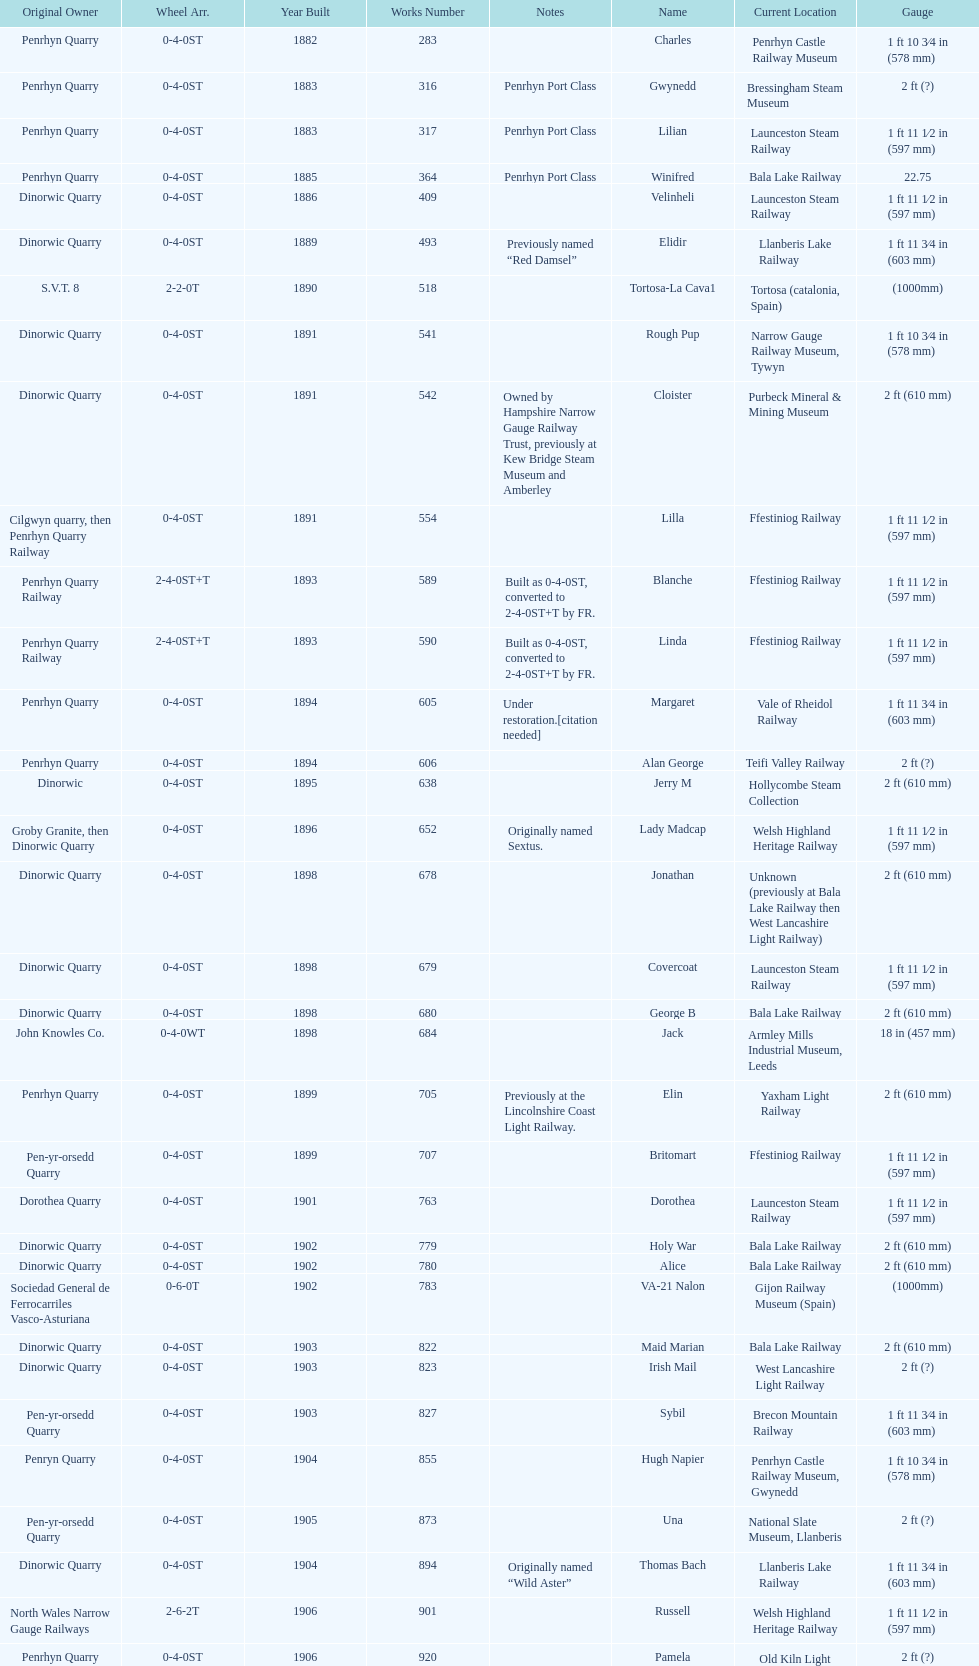Write the full table. {'header': ['Original Owner', 'Wheel Arr.', 'Year Built', 'Works Number', 'Notes', 'Name', 'Current Location', 'Gauge'], 'rows': [['Penrhyn Quarry', '0-4-0ST', '1882', '283', '', 'Charles', 'Penrhyn Castle Railway Museum', '1\xa0ft 10\xa03⁄4\xa0in (578\xa0mm)'], ['Penrhyn Quarry', '0-4-0ST', '1883', '316', 'Penrhyn Port Class', 'Gwynedd', 'Bressingham Steam Museum', '2\xa0ft (?)'], ['Penrhyn Quarry', '0-4-0ST', '1883', '317', 'Penrhyn Port Class', 'Lilian', 'Launceston Steam Railway', '1\xa0ft 11\xa01⁄2\xa0in (597\xa0mm)'], ['Penrhyn Quarry', '0-4-0ST', '1885', '364', 'Penrhyn Port Class', 'Winifred', 'Bala Lake Railway', '22.75'], ['Dinorwic Quarry', '0-4-0ST', '1886', '409', '', 'Velinheli', 'Launceston Steam Railway', '1\xa0ft 11\xa01⁄2\xa0in (597\xa0mm)'], ['Dinorwic Quarry', '0-4-0ST', '1889', '493', 'Previously named “Red Damsel”', 'Elidir', 'Llanberis Lake Railway', '1\xa0ft 11\xa03⁄4\xa0in (603\xa0mm)'], ['S.V.T. 8', '2-2-0T', '1890', '518', '', 'Tortosa-La Cava1', 'Tortosa (catalonia, Spain)', '(1000mm)'], ['Dinorwic Quarry', '0-4-0ST', '1891', '541', '', 'Rough Pup', 'Narrow Gauge Railway Museum, Tywyn', '1\xa0ft 10\xa03⁄4\xa0in (578\xa0mm)'], ['Dinorwic Quarry', '0-4-0ST', '1891', '542', 'Owned by Hampshire Narrow Gauge Railway Trust, previously at Kew Bridge Steam Museum and Amberley', 'Cloister', 'Purbeck Mineral & Mining Museum', '2\xa0ft (610\xa0mm)'], ['Cilgwyn quarry, then Penrhyn Quarry Railway', '0-4-0ST', '1891', '554', '', 'Lilla', 'Ffestiniog Railway', '1\xa0ft 11\xa01⁄2\xa0in (597\xa0mm)'], ['Penrhyn Quarry Railway', '2-4-0ST+T', '1893', '589', 'Built as 0-4-0ST, converted to 2-4-0ST+T by FR.', 'Blanche', 'Ffestiniog Railway', '1\xa0ft 11\xa01⁄2\xa0in (597\xa0mm)'], ['Penrhyn Quarry Railway', '2-4-0ST+T', '1893', '590', 'Built as 0-4-0ST, converted to 2-4-0ST+T by FR.', 'Linda', 'Ffestiniog Railway', '1\xa0ft 11\xa01⁄2\xa0in (597\xa0mm)'], ['Penrhyn Quarry', '0-4-0ST', '1894', '605', 'Under restoration.[citation needed]', 'Margaret', 'Vale of Rheidol Railway', '1\xa0ft 11\xa03⁄4\xa0in (603\xa0mm)'], ['Penrhyn Quarry', '0-4-0ST', '1894', '606', '', 'Alan George', 'Teifi Valley Railway', '2\xa0ft (?)'], ['Dinorwic', '0-4-0ST', '1895', '638', '', 'Jerry M', 'Hollycombe Steam Collection', '2\xa0ft (610\xa0mm)'], ['Groby Granite, then Dinorwic Quarry', '0-4-0ST', '1896', '652', 'Originally named Sextus.', 'Lady Madcap', 'Welsh Highland Heritage Railway', '1\xa0ft 11\xa01⁄2\xa0in (597\xa0mm)'], ['Dinorwic Quarry', '0-4-0ST', '1898', '678', '', 'Jonathan', 'Unknown (previously at Bala Lake Railway then West Lancashire Light Railway)', '2\xa0ft (610\xa0mm)'], ['Dinorwic Quarry', '0-4-0ST', '1898', '679', '', 'Covercoat', 'Launceston Steam Railway', '1\xa0ft 11\xa01⁄2\xa0in (597\xa0mm)'], ['Dinorwic Quarry', '0-4-0ST', '1898', '680', '', 'George B', 'Bala Lake Railway', '2\xa0ft (610\xa0mm)'], ['John Knowles Co.', '0-4-0WT', '1898', '684', '', 'Jack', 'Armley Mills Industrial Museum, Leeds', '18\xa0in (457\xa0mm)'], ['Penrhyn Quarry', '0-4-0ST', '1899', '705', 'Previously at the Lincolnshire Coast Light Railway.', 'Elin', 'Yaxham Light Railway', '2\xa0ft (610\xa0mm)'], ['Pen-yr-orsedd Quarry', '0-4-0ST', '1899', '707', '', 'Britomart', 'Ffestiniog Railway', '1\xa0ft 11\xa01⁄2\xa0in (597\xa0mm)'], ['Dorothea Quarry', '0-4-0ST', '1901', '763', '', 'Dorothea', 'Launceston Steam Railway', '1\xa0ft 11\xa01⁄2\xa0in (597\xa0mm)'], ['Dinorwic Quarry', '0-4-0ST', '1902', '779', '', 'Holy War', 'Bala Lake Railway', '2\xa0ft (610\xa0mm)'], ['Dinorwic Quarry', '0-4-0ST', '1902', '780', '', 'Alice', 'Bala Lake Railway', '2\xa0ft (610\xa0mm)'], ['Sociedad General de Ferrocarriles Vasco-Asturiana', '0-6-0T', '1902', '783', '', 'VA-21 Nalon', 'Gijon Railway Museum (Spain)', '(1000mm)'], ['Dinorwic Quarry', '0-4-0ST', '1903', '822', '', 'Maid Marian', 'Bala Lake Railway', '2\xa0ft (610\xa0mm)'], ['Dinorwic Quarry', '0-4-0ST', '1903', '823', '', 'Irish Mail', 'West Lancashire Light Railway', '2\xa0ft (?)'], ['Pen-yr-orsedd Quarry', '0-4-0ST', '1903', '827', '', 'Sybil', 'Brecon Mountain Railway', '1\xa0ft 11\xa03⁄4\xa0in (603\xa0mm)'], ['Penryn Quarry', '0-4-0ST', '1904', '855', '', 'Hugh Napier', 'Penrhyn Castle Railway Museum, Gwynedd', '1\xa0ft 10\xa03⁄4\xa0in (578\xa0mm)'], ['Pen-yr-orsedd Quarry', '0-4-0ST', '1905', '873', '', 'Una', 'National Slate Museum, Llanberis', '2\xa0ft (?)'], ['Dinorwic Quarry', '0-4-0ST', '1904', '894', 'Originally named “Wild Aster”', 'Thomas Bach', 'Llanberis Lake Railway', '1\xa0ft 11\xa03⁄4\xa0in (603\xa0mm)'], ['North Wales Narrow Gauge Railways', '2-6-2T', '1906', '901', '', 'Russell', 'Welsh Highland Heritage Railway', '1\xa0ft 11\xa01⁄2\xa0in (597\xa0mm)'], ['Penrhyn Quarry', '0-4-0ST', '1906', '920', '', 'Pamela', 'Old Kiln Light Railway', '2\xa0ft (?)'], ['Penrhyn Quarry', '0-4-0ST', '1909', '994', 'previously George Sholto', 'Bill Harvey', 'Bressingham Steam Museum', '2\xa0ft (?)'], ['British War Department\\nEFOP #203', '4-6-0T', '1918', '1312', '[citation needed]', '---', 'Pampas Safari, Gravataí, RS, Brazil', '1\xa0ft\xa011\xa01⁄2\xa0in (597\xa0mm)'], ['British War Department\\nUsina Leão Utinga #1\\nUsina Laginha #1', '0-6-2T', '1918\\nor\\n1921?', '1313', '[citation needed]', '---', 'Usina Laginha, União dos Palmares, AL, Brazil', '3\xa0ft\xa03\xa03⁄8\xa0in (1,000\xa0mm)'], ['John Knowles Co.', '0-4-0WT', '1920', '1404', '', 'Gwen', 'Richard Farmer current owner, Northridge, California, USA', '18\xa0in (457\xa0mm)'], ['Dinorwic', '0-4-0ST', '1922', '1429', '', 'Lady Joan', 'Bredgar and Wormshill Light Railway', '2\xa0ft (610\xa0mm)'], ['Dinorwic Quarry', '0-4-0ST', '1922', '1430', '', 'Dolbadarn', 'Llanberis Lake Railway', '1\xa0ft 11\xa03⁄4\xa0in (603\xa0mm)'], ['Umtwalumi Valley Estate, Natal', '0-4-2T', '1937', '1859', '', '16 Carlisle', 'South Tynedale Railway', '2\xa0ft (?)'], ['Chaka’s Kraal Sugar Estates, Natal', '0-4-2T', '1940', '2075', '', 'Chaka’s Kraal No. 6', 'North Gloucestershire Railway', '2\xa0ft (?)'], ['Sierra Leone Government Railway', '2-6-2T', '1954', '3815', '', '14', 'Welshpool and Llanfair Light Railway', '2\xa0ft 6\xa0in (762\xa0mm)'], ['Trangkil Sugar Mill, Indonesia', '0-4-2ST', '1971', '3902', 'Converted from 750\xa0mm (2\xa0ft\xa05\xa01⁄2\xa0in) gauge. Last steam locomotive to be built by Hunslet, and the last industrial steam locomotive built in Britain.', 'Trangkil No.4', 'Statfold Barn Railway', '2\xa0ft (610\xa0mm)']]} Which original owner had the most locomotives? Penrhyn Quarry. 